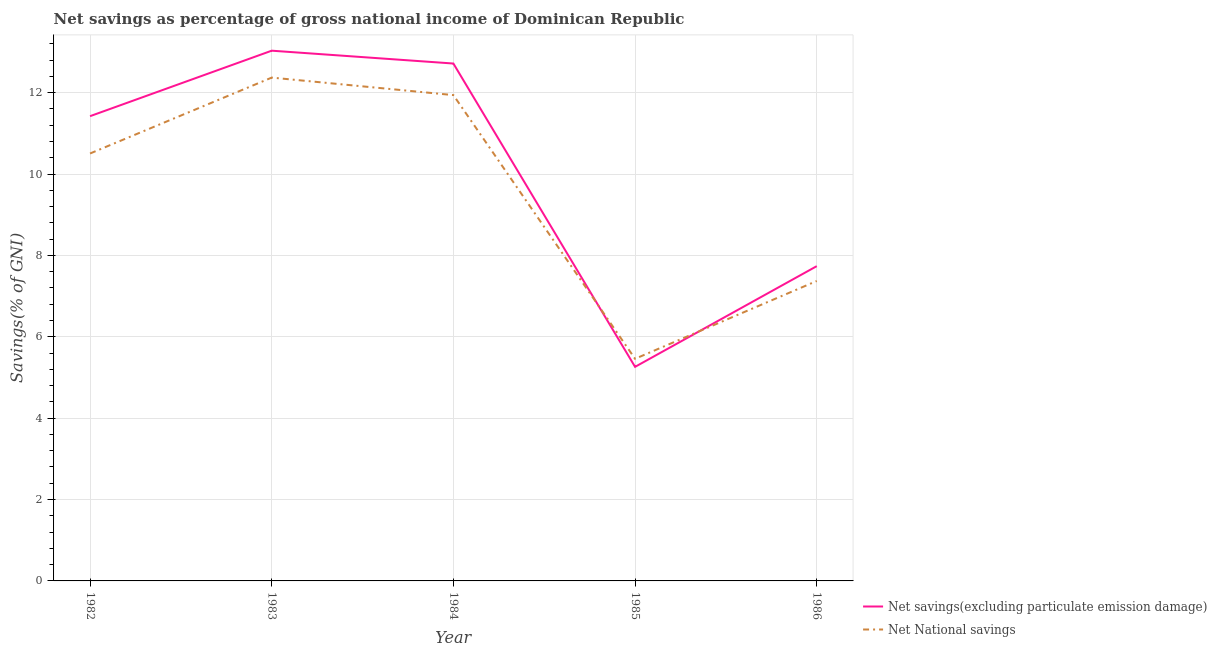Is the number of lines equal to the number of legend labels?
Your response must be concise. Yes. What is the net national savings in 1986?
Your response must be concise. 7.37. Across all years, what is the maximum net savings(excluding particulate emission damage)?
Give a very brief answer. 13.03. Across all years, what is the minimum net savings(excluding particulate emission damage)?
Your response must be concise. 5.26. What is the total net savings(excluding particulate emission damage) in the graph?
Keep it short and to the point. 50.16. What is the difference between the net savings(excluding particulate emission damage) in 1983 and that in 1986?
Offer a very short reply. 5.3. What is the difference between the net national savings in 1986 and the net savings(excluding particulate emission damage) in 1983?
Give a very brief answer. -5.66. What is the average net savings(excluding particulate emission damage) per year?
Offer a terse response. 10.03. In the year 1983, what is the difference between the net savings(excluding particulate emission damage) and net national savings?
Make the answer very short. 0.66. What is the ratio of the net national savings in 1982 to that in 1984?
Make the answer very short. 0.88. What is the difference between the highest and the second highest net national savings?
Provide a short and direct response. 0.43. What is the difference between the highest and the lowest net national savings?
Your response must be concise. 6.91. In how many years, is the net national savings greater than the average net national savings taken over all years?
Provide a short and direct response. 3. Is the sum of the net savings(excluding particulate emission damage) in 1984 and 1985 greater than the maximum net national savings across all years?
Keep it short and to the point. Yes. How many years are there in the graph?
Your answer should be compact. 5. What is the difference between two consecutive major ticks on the Y-axis?
Give a very brief answer. 2. Are the values on the major ticks of Y-axis written in scientific E-notation?
Keep it short and to the point. No. Does the graph contain grids?
Your response must be concise. Yes. Where does the legend appear in the graph?
Offer a terse response. Bottom right. How are the legend labels stacked?
Ensure brevity in your answer.  Vertical. What is the title of the graph?
Your answer should be very brief. Net savings as percentage of gross national income of Dominican Republic. What is the label or title of the Y-axis?
Offer a terse response. Savings(% of GNI). What is the Savings(% of GNI) of Net savings(excluding particulate emission damage) in 1982?
Your answer should be very brief. 11.42. What is the Savings(% of GNI) in Net National savings in 1982?
Your response must be concise. 10.5. What is the Savings(% of GNI) of Net savings(excluding particulate emission damage) in 1983?
Offer a terse response. 13.03. What is the Savings(% of GNI) of Net National savings in 1983?
Your response must be concise. 12.37. What is the Savings(% of GNI) in Net savings(excluding particulate emission damage) in 1984?
Offer a very short reply. 12.71. What is the Savings(% of GNI) of Net National savings in 1984?
Make the answer very short. 11.94. What is the Savings(% of GNI) of Net savings(excluding particulate emission damage) in 1985?
Offer a terse response. 5.26. What is the Savings(% of GNI) of Net National savings in 1985?
Keep it short and to the point. 5.46. What is the Savings(% of GNI) in Net savings(excluding particulate emission damage) in 1986?
Offer a very short reply. 7.74. What is the Savings(% of GNI) in Net National savings in 1986?
Give a very brief answer. 7.37. Across all years, what is the maximum Savings(% of GNI) of Net savings(excluding particulate emission damage)?
Keep it short and to the point. 13.03. Across all years, what is the maximum Savings(% of GNI) of Net National savings?
Provide a short and direct response. 12.37. Across all years, what is the minimum Savings(% of GNI) in Net savings(excluding particulate emission damage)?
Provide a short and direct response. 5.26. Across all years, what is the minimum Savings(% of GNI) of Net National savings?
Give a very brief answer. 5.46. What is the total Savings(% of GNI) of Net savings(excluding particulate emission damage) in the graph?
Ensure brevity in your answer.  50.16. What is the total Savings(% of GNI) in Net National savings in the graph?
Provide a short and direct response. 47.64. What is the difference between the Savings(% of GNI) of Net savings(excluding particulate emission damage) in 1982 and that in 1983?
Offer a very short reply. -1.61. What is the difference between the Savings(% of GNI) of Net National savings in 1982 and that in 1983?
Provide a short and direct response. -1.87. What is the difference between the Savings(% of GNI) of Net savings(excluding particulate emission damage) in 1982 and that in 1984?
Your response must be concise. -1.29. What is the difference between the Savings(% of GNI) of Net National savings in 1982 and that in 1984?
Offer a terse response. -1.44. What is the difference between the Savings(% of GNI) in Net savings(excluding particulate emission damage) in 1982 and that in 1985?
Your answer should be compact. 6.16. What is the difference between the Savings(% of GNI) of Net National savings in 1982 and that in 1985?
Give a very brief answer. 5.05. What is the difference between the Savings(% of GNI) of Net savings(excluding particulate emission damage) in 1982 and that in 1986?
Offer a very short reply. 3.69. What is the difference between the Savings(% of GNI) of Net National savings in 1982 and that in 1986?
Your answer should be very brief. 3.13. What is the difference between the Savings(% of GNI) of Net savings(excluding particulate emission damage) in 1983 and that in 1984?
Your answer should be compact. 0.32. What is the difference between the Savings(% of GNI) in Net National savings in 1983 and that in 1984?
Offer a terse response. 0.43. What is the difference between the Savings(% of GNI) of Net savings(excluding particulate emission damage) in 1983 and that in 1985?
Offer a very short reply. 7.77. What is the difference between the Savings(% of GNI) in Net National savings in 1983 and that in 1985?
Give a very brief answer. 6.91. What is the difference between the Savings(% of GNI) in Net savings(excluding particulate emission damage) in 1983 and that in 1986?
Provide a succinct answer. 5.3. What is the difference between the Savings(% of GNI) in Net National savings in 1983 and that in 1986?
Offer a terse response. 5. What is the difference between the Savings(% of GNI) in Net savings(excluding particulate emission damage) in 1984 and that in 1985?
Offer a very short reply. 7.45. What is the difference between the Savings(% of GNI) of Net National savings in 1984 and that in 1985?
Provide a succinct answer. 6.48. What is the difference between the Savings(% of GNI) of Net savings(excluding particulate emission damage) in 1984 and that in 1986?
Keep it short and to the point. 4.98. What is the difference between the Savings(% of GNI) of Net National savings in 1984 and that in 1986?
Provide a succinct answer. 4.57. What is the difference between the Savings(% of GNI) of Net savings(excluding particulate emission damage) in 1985 and that in 1986?
Keep it short and to the point. -2.47. What is the difference between the Savings(% of GNI) in Net National savings in 1985 and that in 1986?
Provide a succinct answer. -1.91. What is the difference between the Savings(% of GNI) of Net savings(excluding particulate emission damage) in 1982 and the Savings(% of GNI) of Net National savings in 1983?
Your answer should be compact. -0.95. What is the difference between the Savings(% of GNI) of Net savings(excluding particulate emission damage) in 1982 and the Savings(% of GNI) of Net National savings in 1984?
Provide a short and direct response. -0.52. What is the difference between the Savings(% of GNI) of Net savings(excluding particulate emission damage) in 1982 and the Savings(% of GNI) of Net National savings in 1985?
Provide a succinct answer. 5.96. What is the difference between the Savings(% of GNI) in Net savings(excluding particulate emission damage) in 1982 and the Savings(% of GNI) in Net National savings in 1986?
Offer a very short reply. 4.05. What is the difference between the Savings(% of GNI) of Net savings(excluding particulate emission damage) in 1983 and the Savings(% of GNI) of Net National savings in 1984?
Ensure brevity in your answer.  1.09. What is the difference between the Savings(% of GNI) of Net savings(excluding particulate emission damage) in 1983 and the Savings(% of GNI) of Net National savings in 1985?
Provide a succinct answer. 7.57. What is the difference between the Savings(% of GNI) of Net savings(excluding particulate emission damage) in 1983 and the Savings(% of GNI) of Net National savings in 1986?
Provide a succinct answer. 5.66. What is the difference between the Savings(% of GNI) of Net savings(excluding particulate emission damage) in 1984 and the Savings(% of GNI) of Net National savings in 1985?
Provide a succinct answer. 7.26. What is the difference between the Savings(% of GNI) of Net savings(excluding particulate emission damage) in 1984 and the Savings(% of GNI) of Net National savings in 1986?
Your answer should be compact. 5.34. What is the difference between the Savings(% of GNI) of Net savings(excluding particulate emission damage) in 1985 and the Savings(% of GNI) of Net National savings in 1986?
Your response must be concise. -2.11. What is the average Savings(% of GNI) of Net savings(excluding particulate emission damage) per year?
Provide a short and direct response. 10.03. What is the average Savings(% of GNI) in Net National savings per year?
Make the answer very short. 9.53. In the year 1982, what is the difference between the Savings(% of GNI) of Net savings(excluding particulate emission damage) and Savings(% of GNI) of Net National savings?
Give a very brief answer. 0.92. In the year 1983, what is the difference between the Savings(% of GNI) in Net savings(excluding particulate emission damage) and Savings(% of GNI) in Net National savings?
Provide a succinct answer. 0.66. In the year 1984, what is the difference between the Savings(% of GNI) in Net savings(excluding particulate emission damage) and Savings(% of GNI) in Net National savings?
Provide a short and direct response. 0.78. In the year 1985, what is the difference between the Savings(% of GNI) in Net savings(excluding particulate emission damage) and Savings(% of GNI) in Net National savings?
Make the answer very short. -0.2. In the year 1986, what is the difference between the Savings(% of GNI) of Net savings(excluding particulate emission damage) and Savings(% of GNI) of Net National savings?
Make the answer very short. 0.36. What is the ratio of the Savings(% of GNI) in Net savings(excluding particulate emission damage) in 1982 to that in 1983?
Your answer should be very brief. 0.88. What is the ratio of the Savings(% of GNI) of Net National savings in 1982 to that in 1983?
Keep it short and to the point. 0.85. What is the ratio of the Savings(% of GNI) of Net savings(excluding particulate emission damage) in 1982 to that in 1984?
Offer a very short reply. 0.9. What is the ratio of the Savings(% of GNI) in Net National savings in 1982 to that in 1984?
Keep it short and to the point. 0.88. What is the ratio of the Savings(% of GNI) in Net savings(excluding particulate emission damage) in 1982 to that in 1985?
Provide a succinct answer. 2.17. What is the ratio of the Savings(% of GNI) of Net National savings in 1982 to that in 1985?
Make the answer very short. 1.92. What is the ratio of the Savings(% of GNI) in Net savings(excluding particulate emission damage) in 1982 to that in 1986?
Give a very brief answer. 1.48. What is the ratio of the Savings(% of GNI) of Net National savings in 1982 to that in 1986?
Give a very brief answer. 1.43. What is the ratio of the Savings(% of GNI) of Net savings(excluding particulate emission damage) in 1983 to that in 1984?
Keep it short and to the point. 1.02. What is the ratio of the Savings(% of GNI) of Net National savings in 1983 to that in 1984?
Your response must be concise. 1.04. What is the ratio of the Savings(% of GNI) in Net savings(excluding particulate emission damage) in 1983 to that in 1985?
Provide a short and direct response. 2.48. What is the ratio of the Savings(% of GNI) in Net National savings in 1983 to that in 1985?
Offer a very short reply. 2.27. What is the ratio of the Savings(% of GNI) in Net savings(excluding particulate emission damage) in 1983 to that in 1986?
Your response must be concise. 1.68. What is the ratio of the Savings(% of GNI) of Net National savings in 1983 to that in 1986?
Your answer should be compact. 1.68. What is the ratio of the Savings(% of GNI) in Net savings(excluding particulate emission damage) in 1984 to that in 1985?
Your response must be concise. 2.42. What is the ratio of the Savings(% of GNI) of Net National savings in 1984 to that in 1985?
Keep it short and to the point. 2.19. What is the ratio of the Savings(% of GNI) in Net savings(excluding particulate emission damage) in 1984 to that in 1986?
Make the answer very short. 1.64. What is the ratio of the Savings(% of GNI) in Net National savings in 1984 to that in 1986?
Your response must be concise. 1.62. What is the ratio of the Savings(% of GNI) in Net savings(excluding particulate emission damage) in 1985 to that in 1986?
Your answer should be compact. 0.68. What is the ratio of the Savings(% of GNI) of Net National savings in 1985 to that in 1986?
Make the answer very short. 0.74. What is the difference between the highest and the second highest Savings(% of GNI) in Net savings(excluding particulate emission damage)?
Offer a terse response. 0.32. What is the difference between the highest and the second highest Savings(% of GNI) of Net National savings?
Make the answer very short. 0.43. What is the difference between the highest and the lowest Savings(% of GNI) of Net savings(excluding particulate emission damage)?
Your answer should be very brief. 7.77. What is the difference between the highest and the lowest Savings(% of GNI) in Net National savings?
Offer a very short reply. 6.91. 